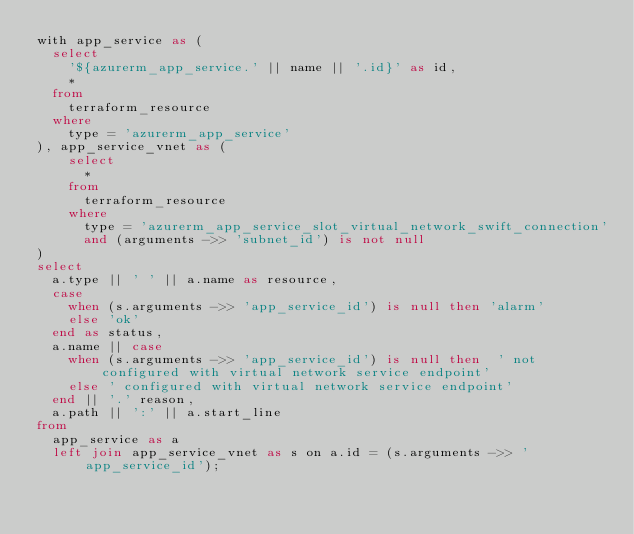<code> <loc_0><loc_0><loc_500><loc_500><_SQL_>with app_service as (
  select
    '${azurerm_app_service.' || name || '.id}' as id,
    *
  from
    terraform_resource
  where
    type = 'azurerm_app_service'
), app_service_vnet as (
    select
      *
    from
      terraform_resource
    where
      type = 'azurerm_app_service_slot_virtual_network_swift_connection'
      and (arguments ->> 'subnet_id') is not null
)
select
  a.type || ' ' || a.name as resource,
  case
    when (s.arguments ->> 'app_service_id') is null then 'alarm'
    else 'ok'
  end as status,
  a.name || case
    when (s.arguments ->> 'app_service_id') is null then  ' not configured with virtual network service endpoint'
    else ' configured with virtual network service endpoint'
  end || '.' reason,
  a.path || ':' || a.start_line
from
  app_service as a
  left join app_service_vnet as s on a.id = (s.arguments ->> 'app_service_id');</code> 